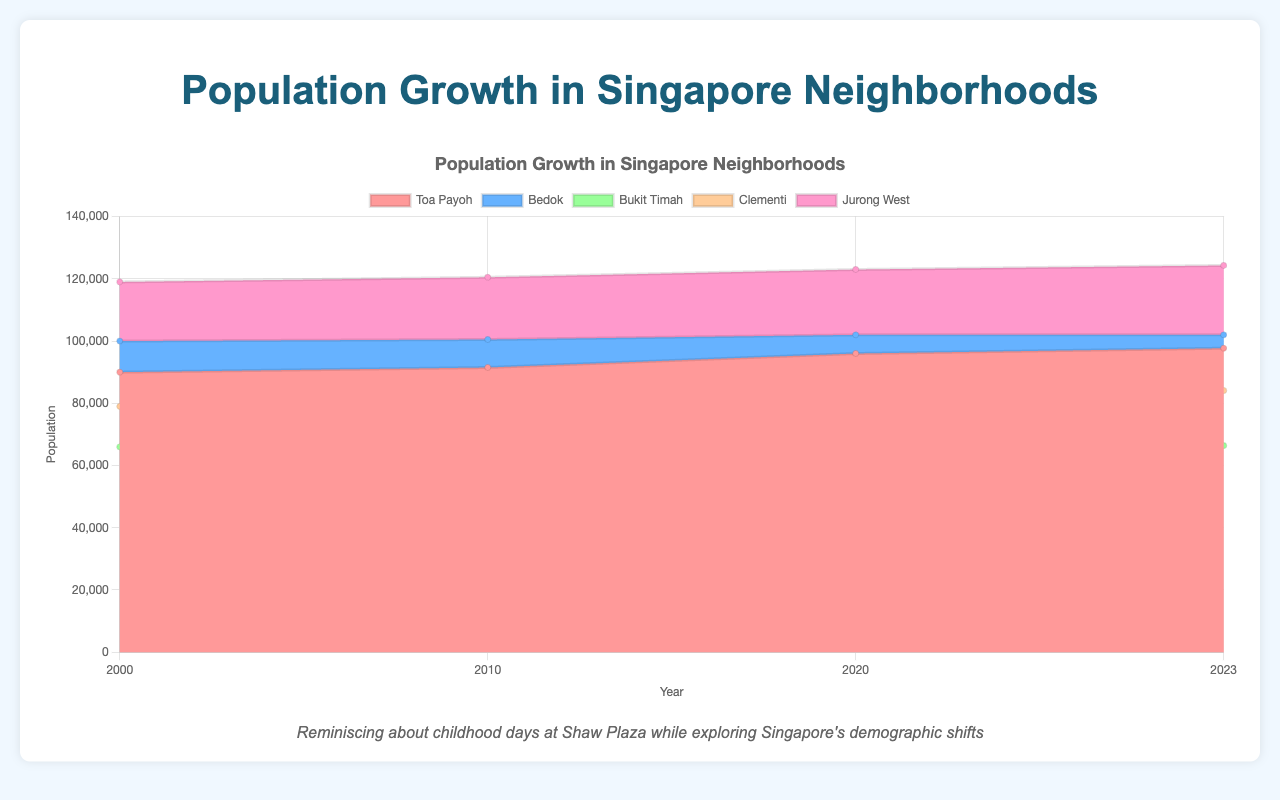What is the title of the area chart? The title of the chart is usually prominently displayed at the top. It provides a context of what the chart represents, helping the viewer to understand the scope of the data. Here, it reads "Population Growth in Singapore Neighborhoods."
Answer: Population Growth in Singapore Neighborhoods Which year marked the peak population for Jurong West according to the chart? By observing the visual peaks of the area chart's line for Jurong West, which is likely distinguished by its specific color, we can see that the highest point occurs in 2000.
Answer: 2000 How does the population of the 0-14 age group in Toa Payoh change from 2000 to 2023? The population numbers for the 0-14 age group in Toa Payoh drop from 15000 in 2000 to 12500 in 2023.
Answer: Decreases by 2500 Compare the population trends of the 65+ age group in Bukit Timah and Clementi between 2000 and 2023. Which neighborhood shows a greater increase? To compare, look at the 65+ demographic population in Bukit Timah (8000 in 2000 to 11000 in 2023) and Clementi (12000 in 2000 to 18000 in 2023). Bukit Timah increases by 3000, while Clementi increases by 6000.
Answer: Clementi What is the combined population of the '25-54' age group across all neighborhoods in 2023? Sum up the '25-54' age group populations from each neighborhood in 2023: 
Toa Payoh: 38500
Bedok: 46000
Bukit Timah: 31000
Clementi: 34500
Jurong West: 57500
Adding these together gives 38500 + 46000 + 31000 + 34500 + 57500 = 207500.
Answer: 207500 Which neighborhood had the most significant total population decline from 2000 to 2023? Calculate the total population for each year (sum of all age groups), then find the difference between 2000 and 2023 for each neighborhood. Bukit Timah's population goes from 66000 in 2000 to 65000 in 2023, a decrease of 1000, which is the most significant decline among the listed neighborhoods.
Answer: Bukit Timah How much did the total population of Bedok change between 2000 and 2023? Calculate the total population in Bedok for 2000 (18000 + 9000 + 50000 + 13000 + 10000) and 2023 (14000 + 9500 + 46000 + 15500 + 17000). In 2000, it's 100000 and in 2023, it's 102000. The change is 102000 - 100000 = 2000.
Answer: Increased by 2000 Which age group shows the highest population increase in Toa Payoh from 2000 to 2023 and by how much? Compare the populations of each age group in 2000 and 2023:
0-14: 15000 to 12500 (decrease)
15-24: 8000 to 8700 (increase of 700)
25-54: 42000 to 38500 (decrease)
55-64: 10000 to 16000 (increase of 6000)
65+: 15000 to 22000 (increase of 7000)
The highest increase is in the '65+' group by 7000.
Answer: 65+ by 7000 How did the total population of the 15-24 age group in Clementi change from 2000 to 2023? The total population in this age group changed from 7000 in 2000 to 7600 in 2023.
Answer: Increased by 600 Of the neighborhoods listed, which one had the highest population in the '25-54' age group in any given year, and what was the value? For each year, check the populations:
2000: Jurong West (60000)
2010: Jurong West (59000)
2020: Jurong West (58000)
2023: Jurong West (57500)
The peak value is 60000 in 2000 in Jurong West.
Answer: Jurong West with 60000 in 2000 